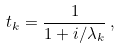Convert formula to latex. <formula><loc_0><loc_0><loc_500><loc_500>t _ { k } = \frac { 1 } { 1 + i / \lambda _ { k } } \, ,</formula> 